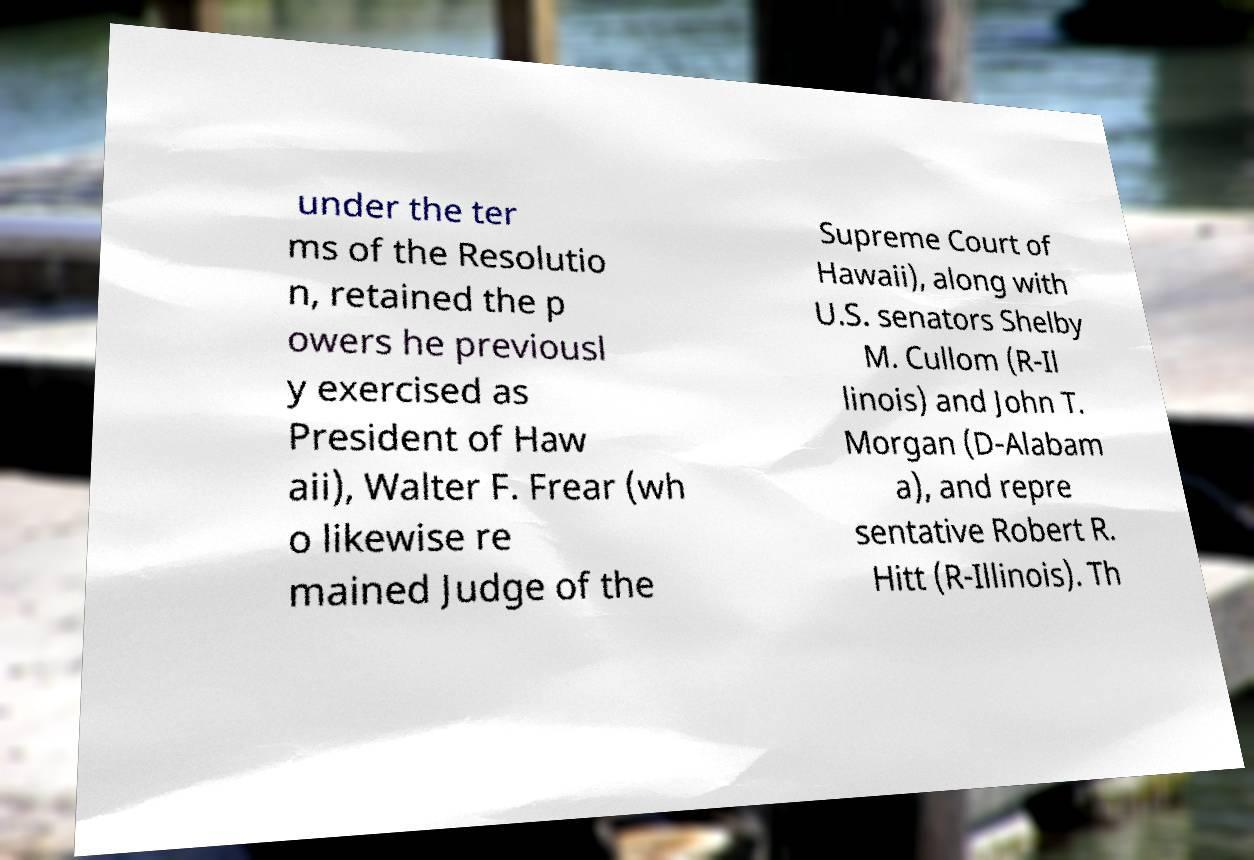I need the written content from this picture converted into text. Can you do that? under the ter ms of the Resolutio n, retained the p owers he previousl y exercised as President of Haw aii), Walter F. Frear (wh o likewise re mained Judge of the Supreme Court of Hawaii), along with U.S. senators Shelby M. Cullom (R-Il linois) and John T. Morgan (D-Alabam a), and repre sentative Robert R. Hitt (R-Illinois). Th 